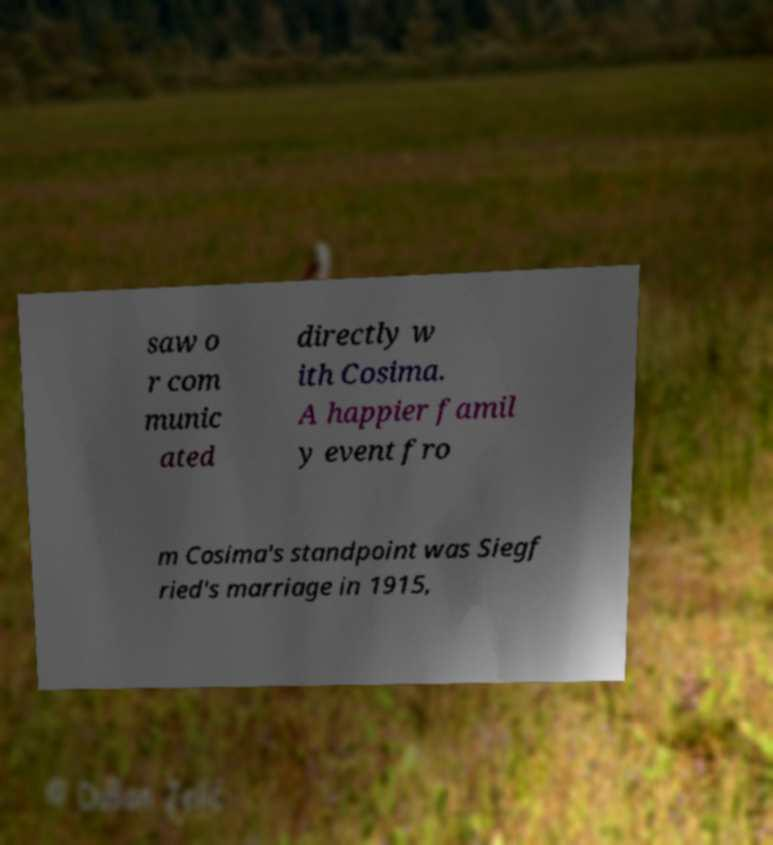Can you accurately transcribe the text from the provided image for me? saw o r com munic ated directly w ith Cosima. A happier famil y event fro m Cosima's standpoint was Siegf ried's marriage in 1915, 